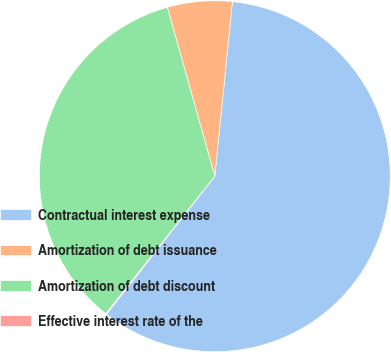Convert chart to OTSL. <chart><loc_0><loc_0><loc_500><loc_500><pie_chart><fcel>Contractual interest expense<fcel>Amortization of debt issuance<fcel>Amortization of debt discount<fcel>Effective interest rate of the<nl><fcel>58.99%<fcel>5.96%<fcel>34.98%<fcel>0.07%<nl></chart> 